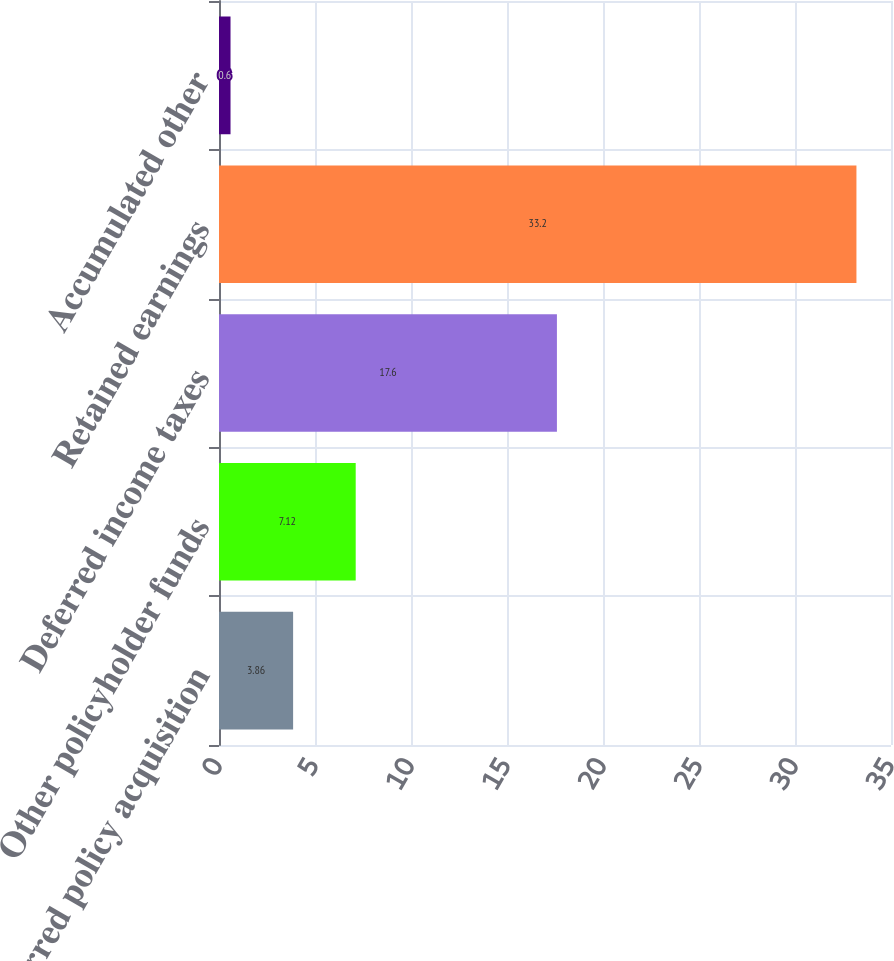Convert chart. <chart><loc_0><loc_0><loc_500><loc_500><bar_chart><fcel>Deferred policy acquisition<fcel>Other policyholder funds<fcel>Deferred income taxes<fcel>Retained earnings<fcel>Accumulated other<nl><fcel>3.86<fcel>7.12<fcel>17.6<fcel>33.2<fcel>0.6<nl></chart> 